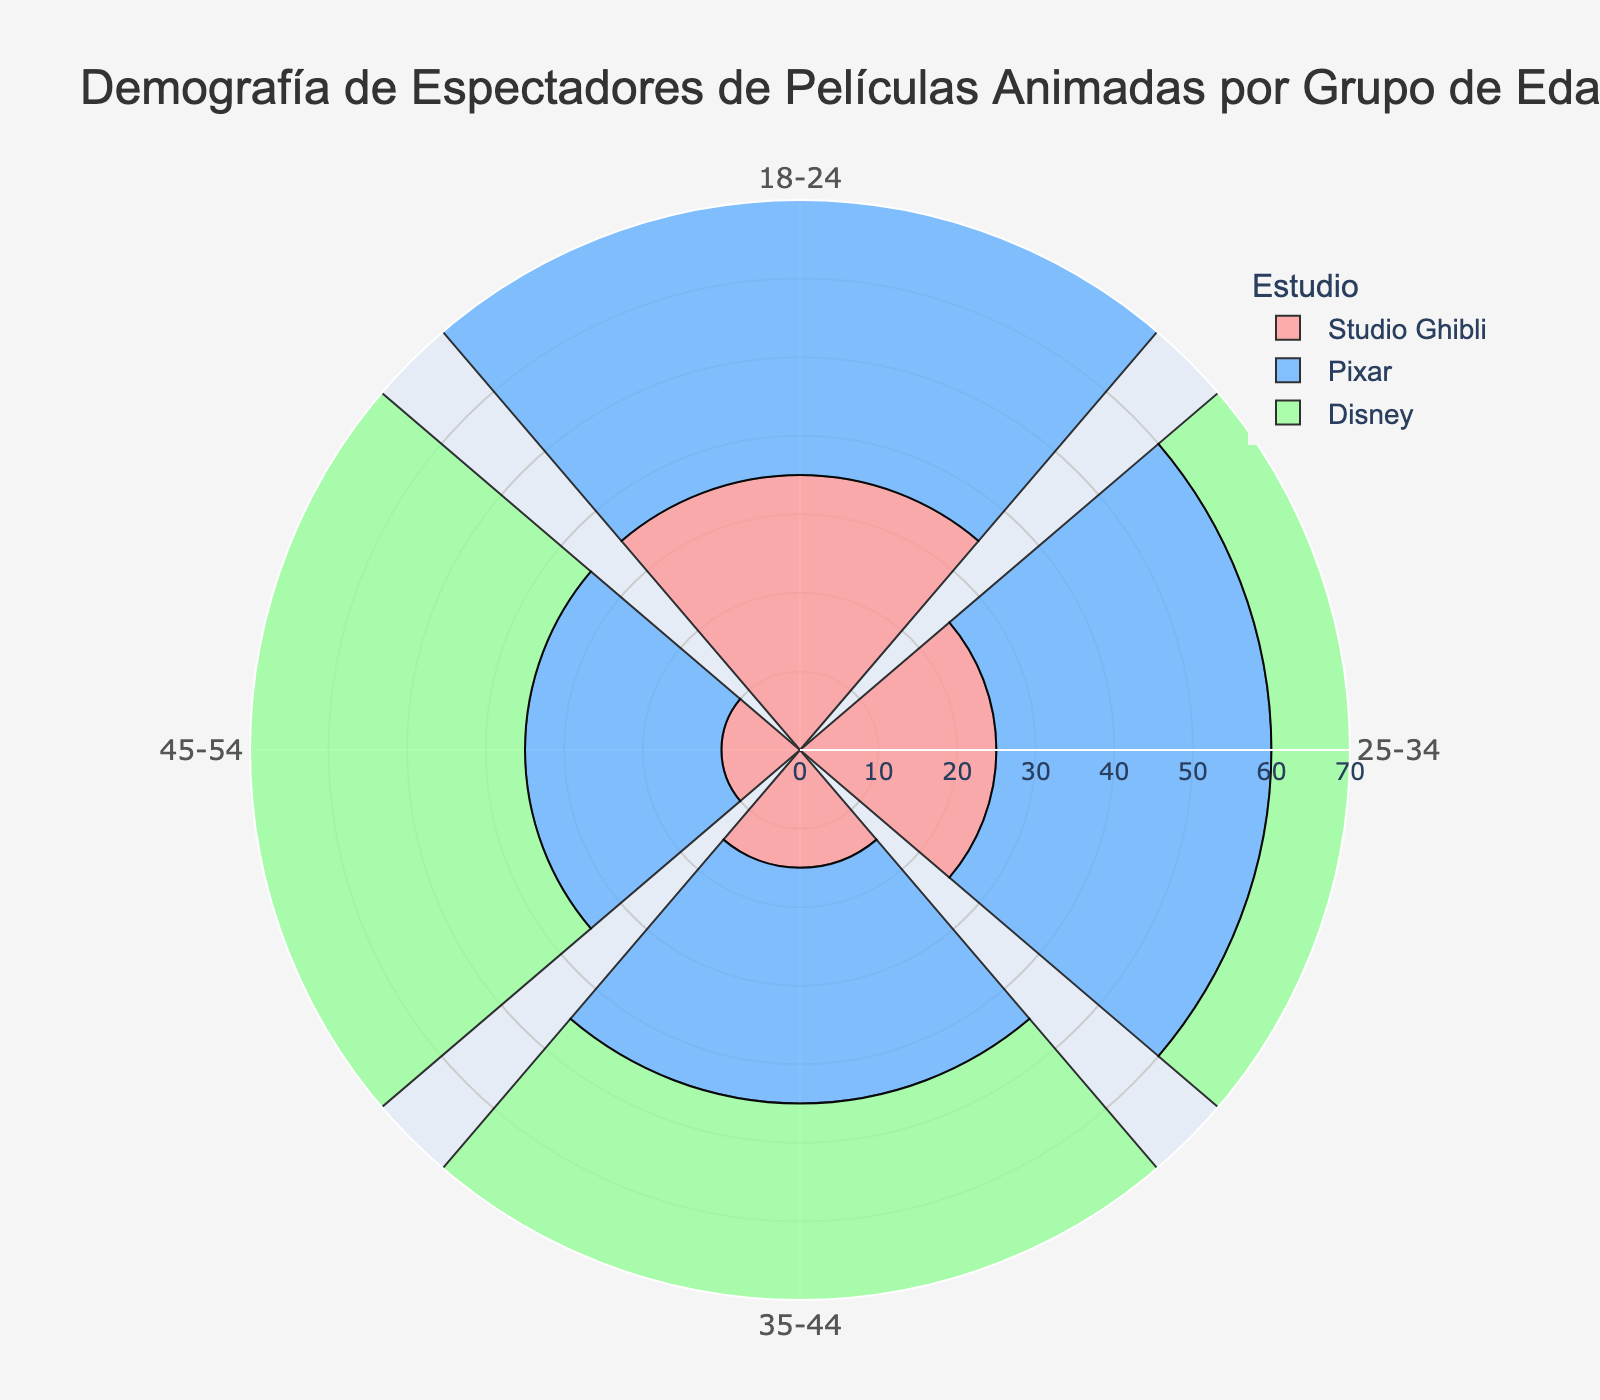Which studio has the most viewers aged 45-54? The figure shows different age groups' preference for Studio Ghibli, Pixar, and Disney. By looking at the data for the 45-54 age group, Disney has the highest number with 65 viewers, compared to Studio Ghibli's 10 and Pixar's 25.
Answer: Disney What is the total number of viewers aged 18-24 across all studios? Sum the viewers for each studio in the 18-24 age group: Studio Ghibli (35) + Pixar (40) + Disney (25). So, the total is 35 + 40 + 25 = 100 viewers.
Answer: 100 Which studio has the smallest audience for the 35-44 age group? Compare the viewer counts for each studio for the 35-44 age group: Studio Ghibli (15), Pixar (30), and Disney (55). The smallest audience is for Studio Ghibli, which has 15 viewers.
Answer: Studio Ghibli How much more popular is Disney than Studio Ghibli among the 25-34 age group? Subtract the number of viewers for Studio Ghibli from those of Disney among the 25-34 age group: Disney (40) - Studio Ghibli (25) = 15. So, Disney is 15 viewers more popular.
Answer: 15 Which age group shows the highest preference for Pixar? By inspecting the data for each age group, Pixar has the highest viewer count in the 18-24 age group with 40 viewers, compared to other groups’ 35, 30, and 25 viewers.
Answer: 18-24 What is the average number of viewers for Studio Ghibli across all age groups? Sum the number of viewers for Studio Ghibli across all age groups and divide by the number of age groups: (35 + 25 + 15 + 10) / 4 = 85 / 4 = 21.25.
Answer: 21.25 How many age groups have more than 30 viewers for both Pixar and Disney? Check each age group: 18-24 (40 for Pixar, 25 for Disney - False), 25-34 (35 for Pixar, 40 for Disney - True), 35-44 (30 for Pixar, 55 for Disney - True), 45-54 (25 for Pixar, 65 for Disney - False). Only two age groups qualify: 25-34 and 35-44.
Answer: 2 What is the percentage of viewers aged 45-54 for Pixar compared to the total number of viewers aged 45-54? The total number of viewers aged 45-54 is 10 (Studio Ghibli) + 25 (Pixar) + 65 (Disney) = 100. The percentage for Pixar is (25 / 100) * 100% = 25%.
Answer: 25% 